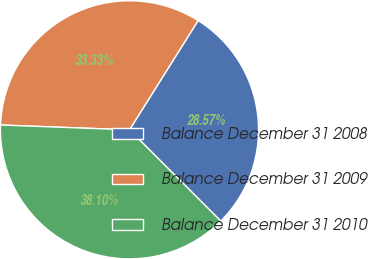<chart> <loc_0><loc_0><loc_500><loc_500><pie_chart><fcel>Balance December 31 2008<fcel>Balance December 31 2009<fcel>Balance December 31 2010<nl><fcel>28.57%<fcel>33.33%<fcel>38.1%<nl></chart> 